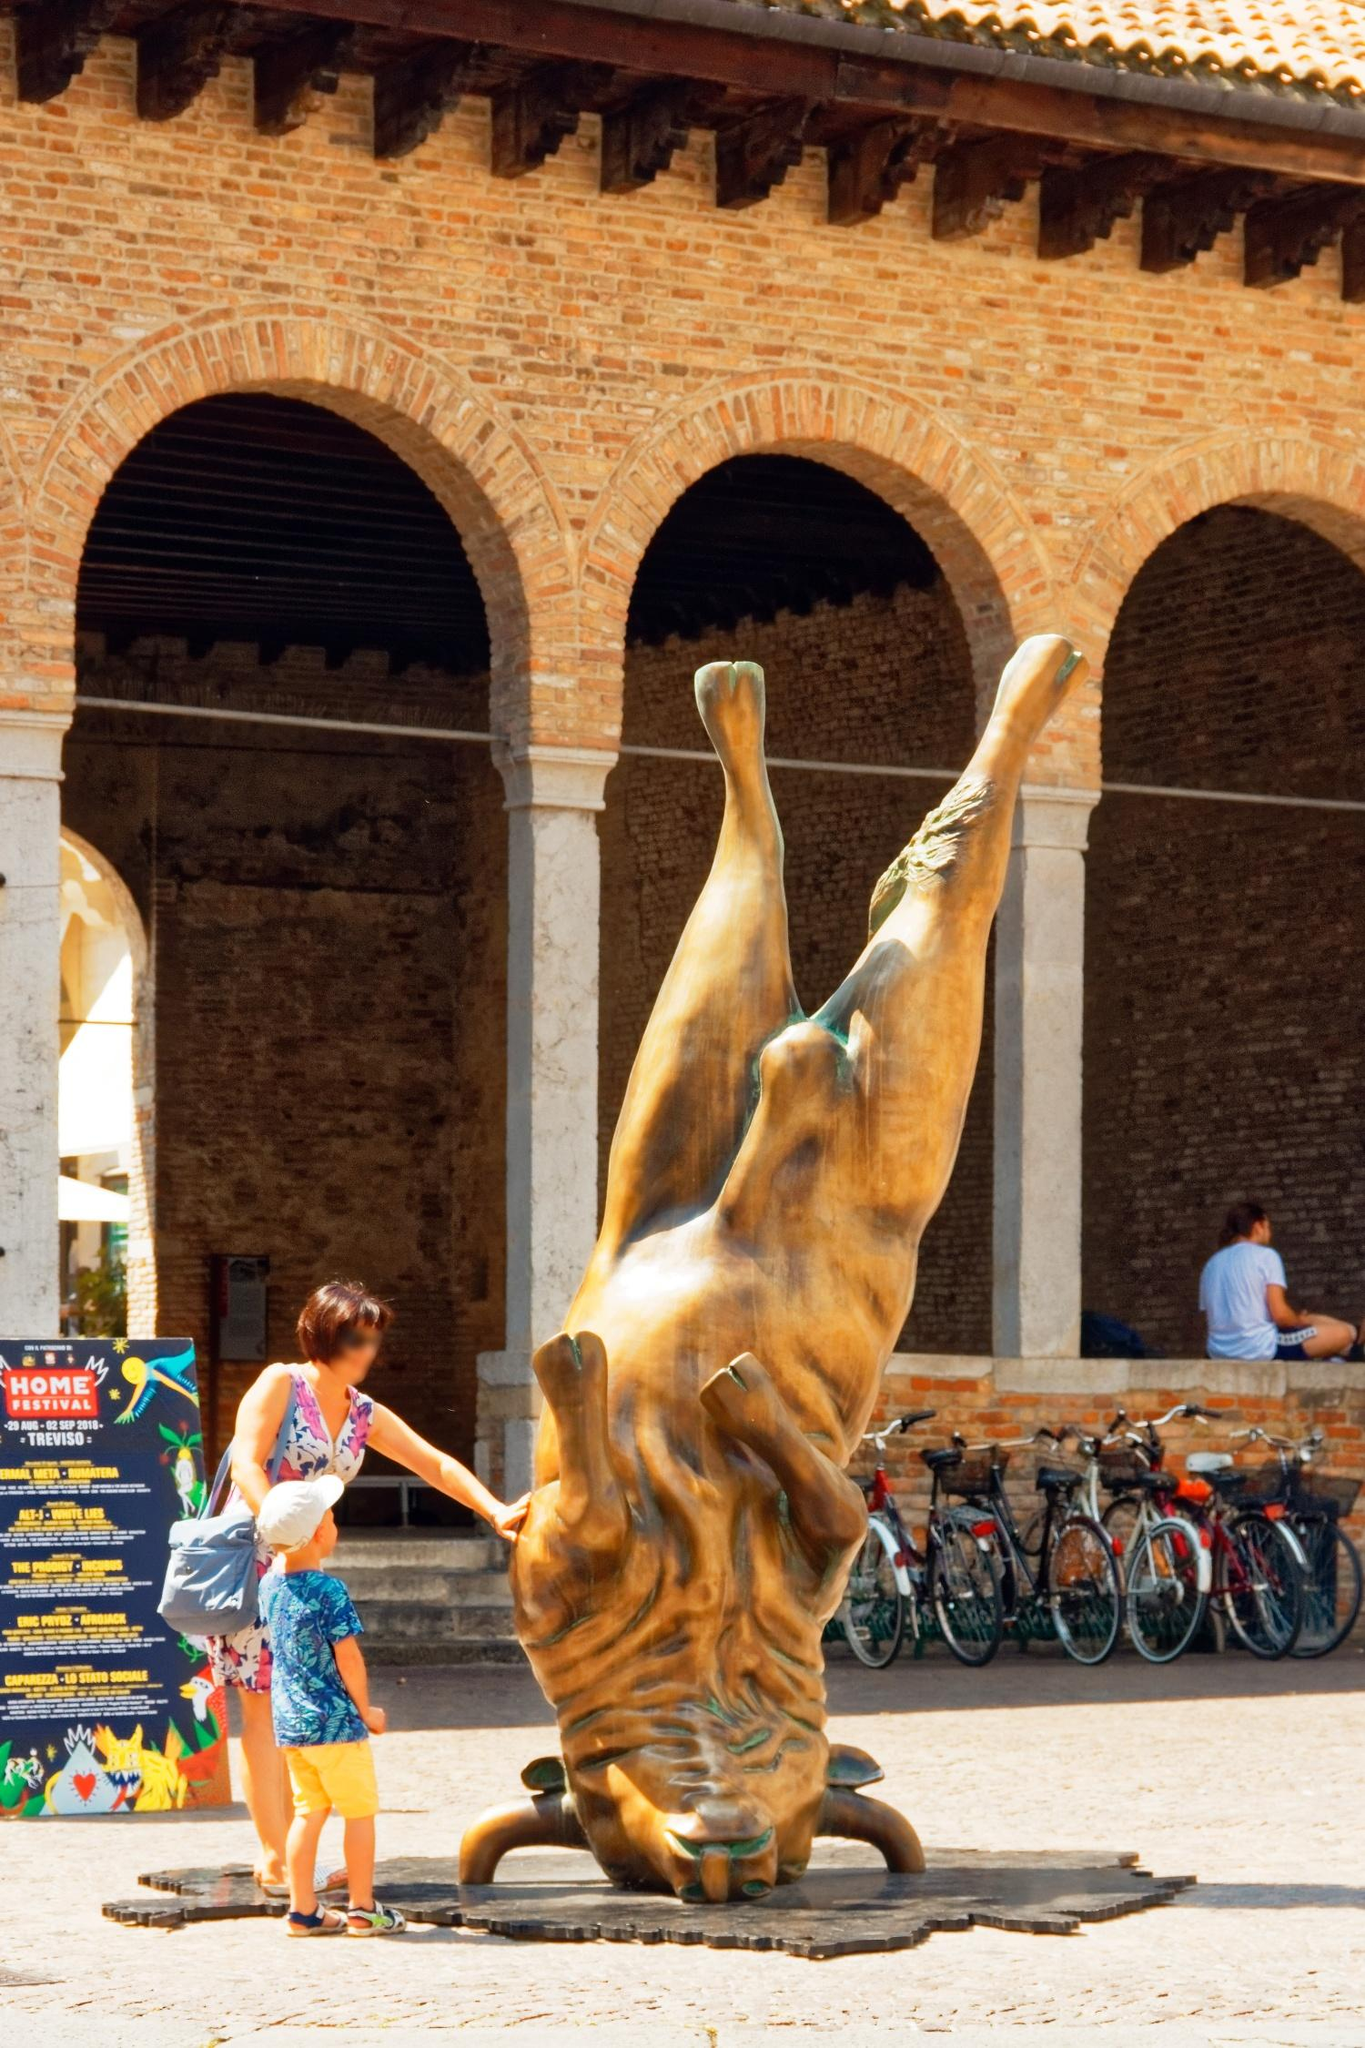What might be the historical significance of the courtyard seen in the image? The courtyard depicted in the image is part of the Castello Sforzesco, a prominent castle in Milan with deep historical roots. The Castello Sforzesco has been a significant structure since the 15th century when Francesco Sforza, Duke of Milan, reconstructed it from its earlier foundations. Over the centuries, it has shifted from being a military fortification to a ducal residency, and now serves as a museum and cultural center.

The brick arches and architectural design speak to the Renaissance-era craftsmanship, reflecting the castle's importance during that period. The courtyard itself is a space where countless historical figures, from Italian nobility to foreign dignitaries, might have walked. It has likely witnessed numerous events pivotal to Milan's history, from gala events and political meetings to arts and cultural exhibitions.

Today, the courtyard remains a testament to Milan's rich historical tapestry, while adapting to contemporary needs as a cultural venue, bridging the past with the present in a seamless fashion. 